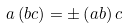<formula> <loc_0><loc_0><loc_500><loc_500>a \left ( b c \right ) = \pm \left ( a b \right ) c</formula> 